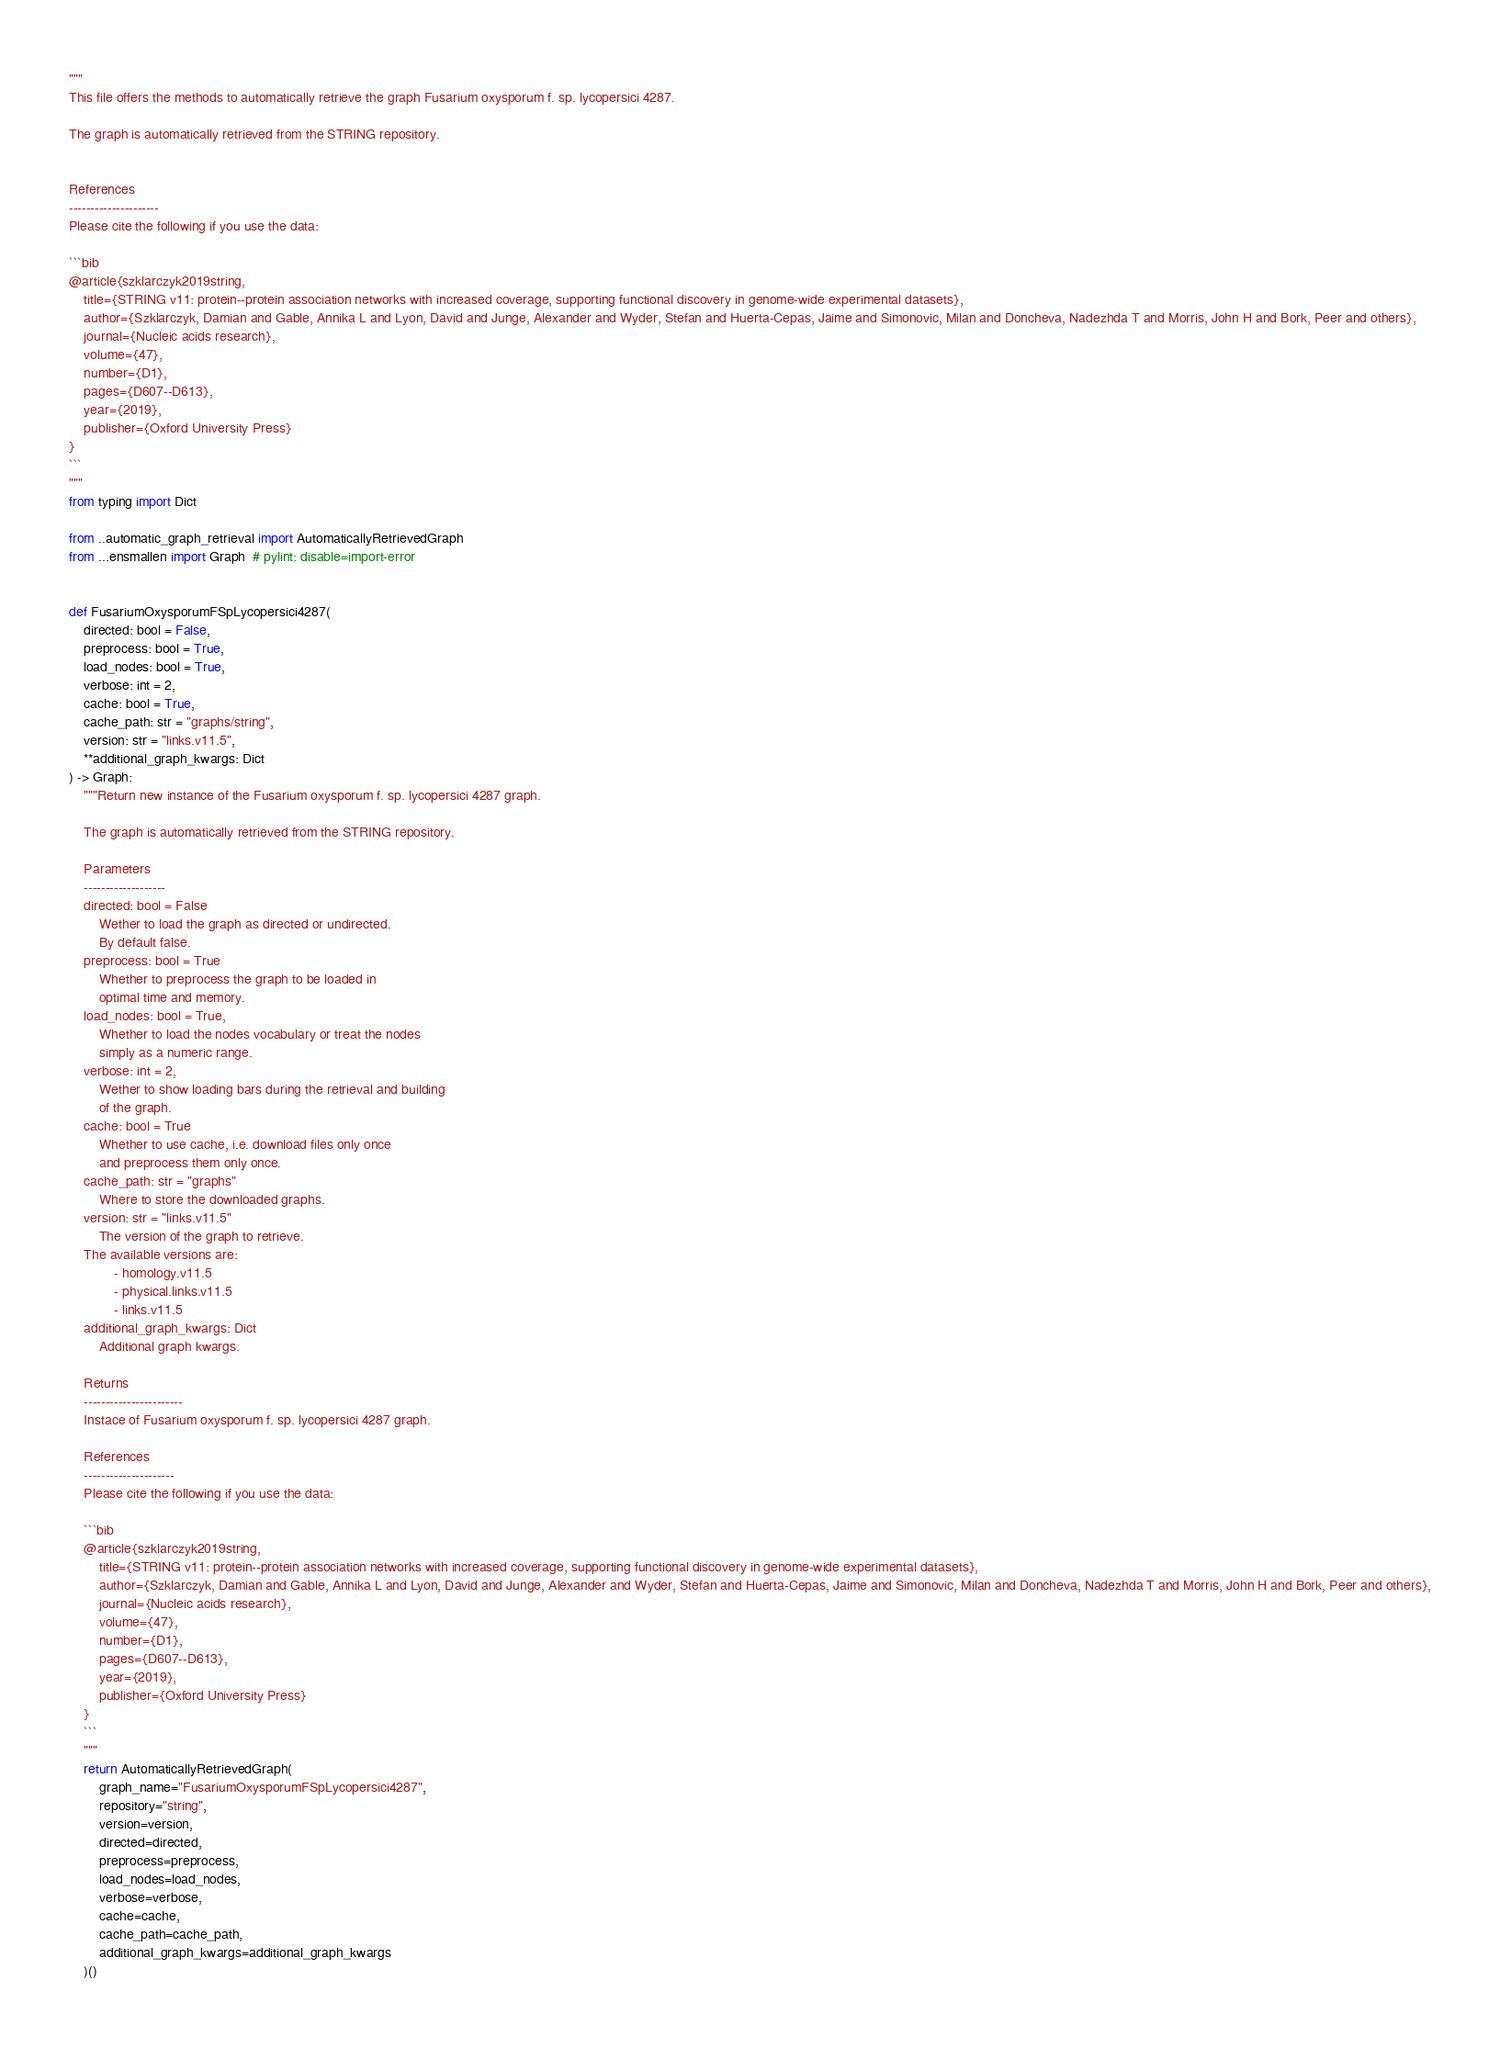Convert code to text. <code><loc_0><loc_0><loc_500><loc_500><_Python_>"""
This file offers the methods to automatically retrieve the graph Fusarium oxysporum f. sp. lycopersici 4287.

The graph is automatically retrieved from the STRING repository. 


References
---------------------
Please cite the following if you use the data:

```bib
@article{szklarczyk2019string,
    title={STRING v11: protein--protein association networks with increased coverage, supporting functional discovery in genome-wide experimental datasets},
    author={Szklarczyk, Damian and Gable, Annika L and Lyon, David and Junge, Alexander and Wyder, Stefan and Huerta-Cepas, Jaime and Simonovic, Milan and Doncheva, Nadezhda T and Morris, John H and Bork, Peer and others},
    journal={Nucleic acids research},
    volume={47},
    number={D1},
    pages={D607--D613},
    year={2019},
    publisher={Oxford University Press}
}
```
"""
from typing import Dict

from ..automatic_graph_retrieval import AutomaticallyRetrievedGraph
from ...ensmallen import Graph  # pylint: disable=import-error


def FusariumOxysporumFSpLycopersici4287(
    directed: bool = False,
    preprocess: bool = True,
    load_nodes: bool = True,
    verbose: int = 2,
    cache: bool = True,
    cache_path: str = "graphs/string",
    version: str = "links.v11.5",
    **additional_graph_kwargs: Dict
) -> Graph:
    """Return new instance of the Fusarium oxysporum f. sp. lycopersici 4287 graph.

    The graph is automatically retrieved from the STRING repository.	

    Parameters
    -------------------
    directed: bool = False
        Wether to load the graph as directed or undirected.
        By default false.
    preprocess: bool = True
        Whether to preprocess the graph to be loaded in 
        optimal time and memory.
    load_nodes: bool = True,
        Whether to load the nodes vocabulary or treat the nodes
        simply as a numeric range.
    verbose: int = 2,
        Wether to show loading bars during the retrieval and building
        of the graph.
    cache: bool = True
        Whether to use cache, i.e. download files only once
        and preprocess them only once.
    cache_path: str = "graphs"
        Where to store the downloaded graphs.
    version: str = "links.v11.5"
        The version of the graph to retrieve.		
	The available versions are:
			- homology.v11.5
			- physical.links.v11.5
			- links.v11.5
    additional_graph_kwargs: Dict
        Additional graph kwargs.

    Returns
    -----------------------
    Instace of Fusarium oxysporum f. sp. lycopersici 4287 graph.

	References
	---------------------
	Please cite the following if you use the data:
	
	```bib
	@article{szklarczyk2019string,
	    title={STRING v11: protein--protein association networks with increased coverage, supporting functional discovery in genome-wide experimental datasets},
	    author={Szklarczyk, Damian and Gable, Annika L and Lyon, David and Junge, Alexander and Wyder, Stefan and Huerta-Cepas, Jaime and Simonovic, Milan and Doncheva, Nadezhda T and Morris, John H and Bork, Peer and others},
	    journal={Nucleic acids research},
	    volume={47},
	    number={D1},
	    pages={D607--D613},
	    year={2019},
	    publisher={Oxford University Press}
	}
	```
    """
    return AutomaticallyRetrievedGraph(
        graph_name="FusariumOxysporumFSpLycopersici4287",
        repository="string",
        version=version,
        directed=directed,
        preprocess=preprocess,
        load_nodes=load_nodes,
        verbose=verbose,
        cache=cache,
        cache_path=cache_path,
        additional_graph_kwargs=additional_graph_kwargs
    )()
</code> 